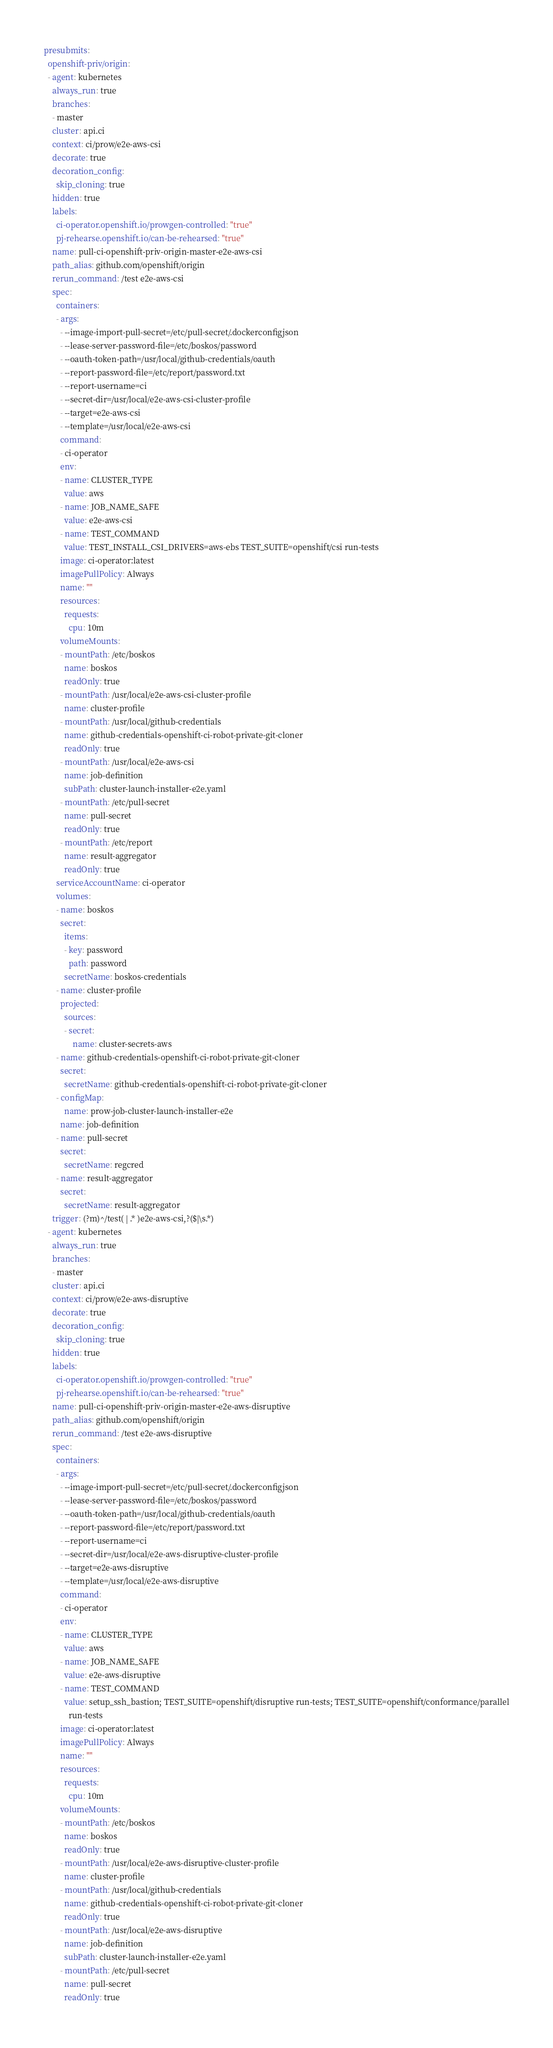Convert code to text. <code><loc_0><loc_0><loc_500><loc_500><_YAML_>presubmits:
  openshift-priv/origin:
  - agent: kubernetes
    always_run: true
    branches:
    - master
    cluster: api.ci
    context: ci/prow/e2e-aws-csi
    decorate: true
    decoration_config:
      skip_cloning: true
    hidden: true
    labels:
      ci-operator.openshift.io/prowgen-controlled: "true"
      pj-rehearse.openshift.io/can-be-rehearsed: "true"
    name: pull-ci-openshift-priv-origin-master-e2e-aws-csi
    path_alias: github.com/openshift/origin
    rerun_command: /test e2e-aws-csi
    spec:
      containers:
      - args:
        - --image-import-pull-secret=/etc/pull-secret/.dockerconfigjson
        - --lease-server-password-file=/etc/boskos/password
        - --oauth-token-path=/usr/local/github-credentials/oauth
        - --report-password-file=/etc/report/password.txt
        - --report-username=ci
        - --secret-dir=/usr/local/e2e-aws-csi-cluster-profile
        - --target=e2e-aws-csi
        - --template=/usr/local/e2e-aws-csi
        command:
        - ci-operator
        env:
        - name: CLUSTER_TYPE
          value: aws
        - name: JOB_NAME_SAFE
          value: e2e-aws-csi
        - name: TEST_COMMAND
          value: TEST_INSTALL_CSI_DRIVERS=aws-ebs TEST_SUITE=openshift/csi run-tests
        image: ci-operator:latest
        imagePullPolicy: Always
        name: ""
        resources:
          requests:
            cpu: 10m
        volumeMounts:
        - mountPath: /etc/boskos
          name: boskos
          readOnly: true
        - mountPath: /usr/local/e2e-aws-csi-cluster-profile
          name: cluster-profile
        - mountPath: /usr/local/github-credentials
          name: github-credentials-openshift-ci-robot-private-git-cloner
          readOnly: true
        - mountPath: /usr/local/e2e-aws-csi
          name: job-definition
          subPath: cluster-launch-installer-e2e.yaml
        - mountPath: /etc/pull-secret
          name: pull-secret
          readOnly: true
        - mountPath: /etc/report
          name: result-aggregator
          readOnly: true
      serviceAccountName: ci-operator
      volumes:
      - name: boskos
        secret:
          items:
          - key: password
            path: password
          secretName: boskos-credentials
      - name: cluster-profile
        projected:
          sources:
          - secret:
              name: cluster-secrets-aws
      - name: github-credentials-openshift-ci-robot-private-git-cloner
        secret:
          secretName: github-credentials-openshift-ci-robot-private-git-cloner
      - configMap:
          name: prow-job-cluster-launch-installer-e2e
        name: job-definition
      - name: pull-secret
        secret:
          secretName: regcred
      - name: result-aggregator
        secret:
          secretName: result-aggregator
    trigger: (?m)^/test( | .* )e2e-aws-csi,?($|\s.*)
  - agent: kubernetes
    always_run: true
    branches:
    - master
    cluster: api.ci
    context: ci/prow/e2e-aws-disruptive
    decorate: true
    decoration_config:
      skip_cloning: true
    hidden: true
    labels:
      ci-operator.openshift.io/prowgen-controlled: "true"
      pj-rehearse.openshift.io/can-be-rehearsed: "true"
    name: pull-ci-openshift-priv-origin-master-e2e-aws-disruptive
    path_alias: github.com/openshift/origin
    rerun_command: /test e2e-aws-disruptive
    spec:
      containers:
      - args:
        - --image-import-pull-secret=/etc/pull-secret/.dockerconfigjson
        - --lease-server-password-file=/etc/boskos/password
        - --oauth-token-path=/usr/local/github-credentials/oauth
        - --report-password-file=/etc/report/password.txt
        - --report-username=ci
        - --secret-dir=/usr/local/e2e-aws-disruptive-cluster-profile
        - --target=e2e-aws-disruptive
        - --template=/usr/local/e2e-aws-disruptive
        command:
        - ci-operator
        env:
        - name: CLUSTER_TYPE
          value: aws
        - name: JOB_NAME_SAFE
          value: e2e-aws-disruptive
        - name: TEST_COMMAND
          value: setup_ssh_bastion; TEST_SUITE=openshift/disruptive run-tests; TEST_SUITE=openshift/conformance/parallel
            run-tests
        image: ci-operator:latest
        imagePullPolicy: Always
        name: ""
        resources:
          requests:
            cpu: 10m
        volumeMounts:
        - mountPath: /etc/boskos
          name: boskos
          readOnly: true
        - mountPath: /usr/local/e2e-aws-disruptive-cluster-profile
          name: cluster-profile
        - mountPath: /usr/local/github-credentials
          name: github-credentials-openshift-ci-robot-private-git-cloner
          readOnly: true
        - mountPath: /usr/local/e2e-aws-disruptive
          name: job-definition
          subPath: cluster-launch-installer-e2e.yaml
        - mountPath: /etc/pull-secret
          name: pull-secret
          readOnly: true</code> 